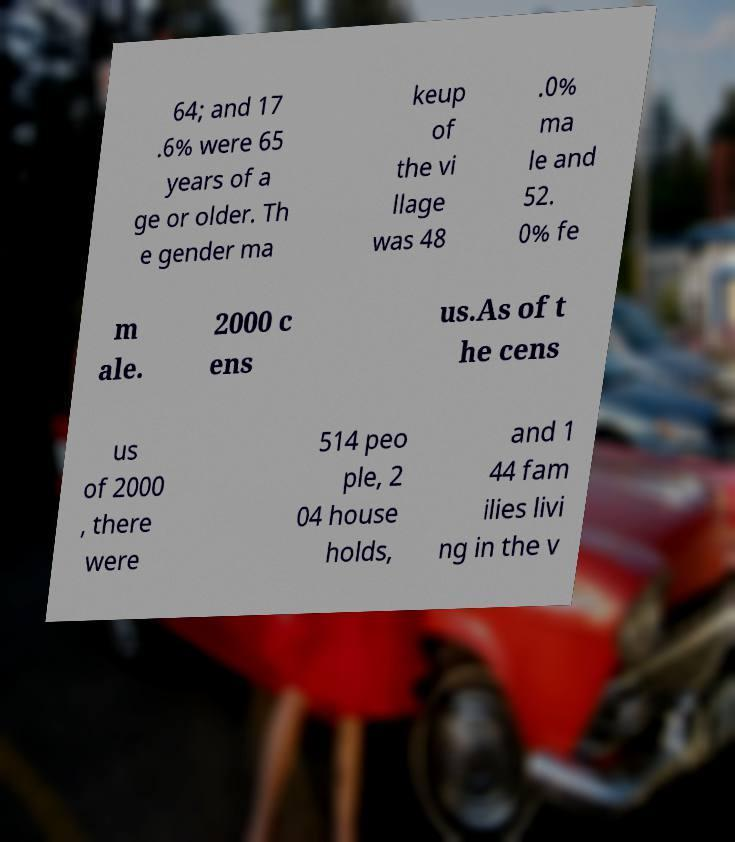Could you extract and type out the text from this image? 64; and 17 .6% were 65 years of a ge or older. Th e gender ma keup of the vi llage was 48 .0% ma le and 52. 0% fe m ale. 2000 c ens us.As of t he cens us of 2000 , there were 514 peo ple, 2 04 house holds, and 1 44 fam ilies livi ng in the v 